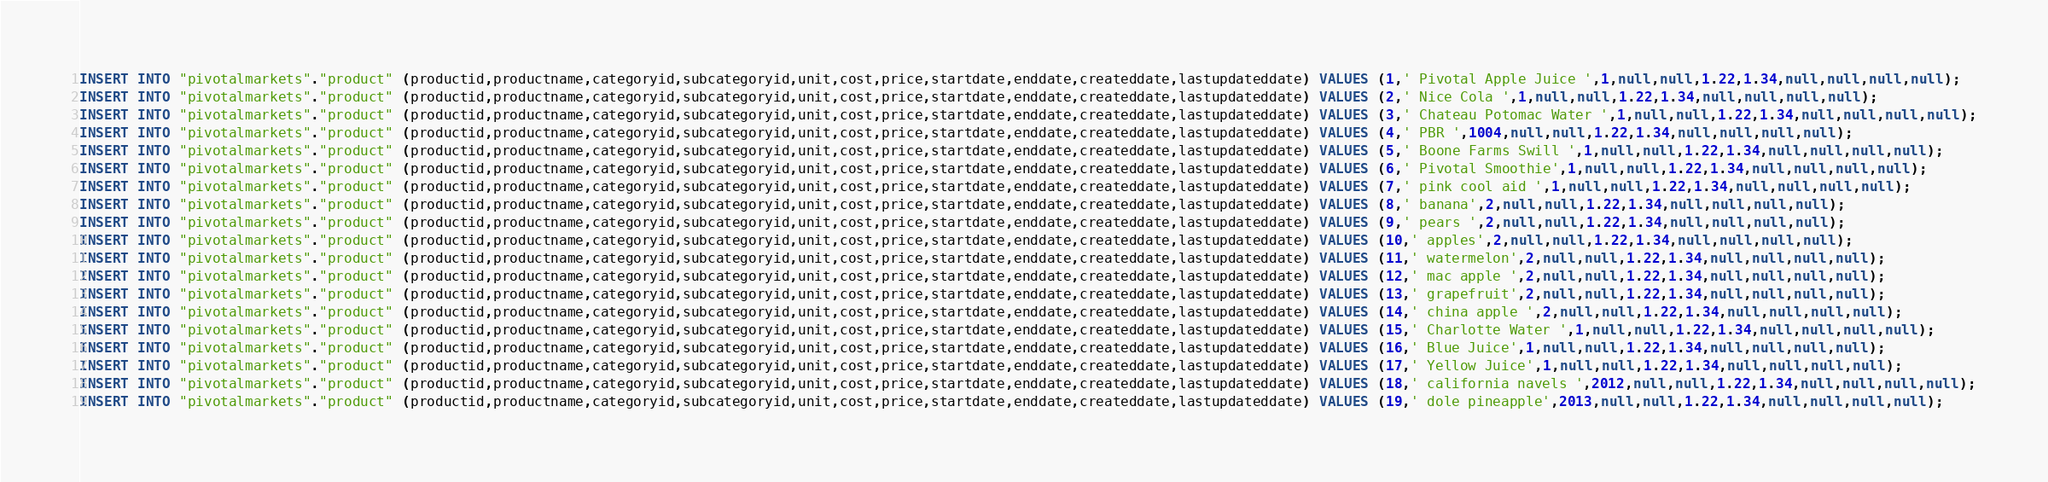<code> <loc_0><loc_0><loc_500><loc_500><_SQL_>

INSERT INTO "pivotalmarkets"."product" (productid,productname,categoryid,subcategoryid,unit,cost,price,startdate,enddate,createddate,lastupdateddate) VALUES (1,' Pivotal Apple Juice ',1,null,null,1.22,1.34,null,null,null,null);
INSERT INTO "pivotalmarkets"."product" (productid,productname,categoryid,subcategoryid,unit,cost,price,startdate,enddate,createddate,lastupdateddate) VALUES (2,' Nice Cola ',1,null,null,1.22,1.34,null,null,null,null);
INSERT INTO "pivotalmarkets"."product" (productid,productname,categoryid,subcategoryid,unit,cost,price,startdate,enddate,createddate,lastupdateddate) VALUES (3,' Chateau Potomac Water ',1,null,null,1.22,1.34,null,null,null,null);
INSERT INTO "pivotalmarkets"."product" (productid,productname,categoryid,subcategoryid,unit,cost,price,startdate,enddate,createddate,lastupdateddate) VALUES (4,' PBR ',1004,null,null,1.22,1.34,null,null,null,null);
INSERT INTO "pivotalmarkets"."product" (productid,productname,categoryid,subcategoryid,unit,cost,price,startdate,enddate,createddate,lastupdateddate) VALUES (5,' Boone Farms Swill ',1,null,null,1.22,1.34,null,null,null,null);
INSERT INTO "pivotalmarkets"."product" (productid,productname,categoryid,subcategoryid,unit,cost,price,startdate,enddate,createddate,lastupdateddate) VALUES (6,' Pivotal Smoothie',1,null,null,1.22,1.34,null,null,null,null);
INSERT INTO "pivotalmarkets"."product" (productid,productname,categoryid,subcategoryid,unit,cost,price,startdate,enddate,createddate,lastupdateddate) VALUES (7,' pink cool aid ',1,null,null,1.22,1.34,null,null,null,null);
INSERT INTO "pivotalmarkets"."product" (productid,productname,categoryid,subcategoryid,unit,cost,price,startdate,enddate,createddate,lastupdateddate) VALUES (8,' banana',2,null,null,1.22,1.34,null,null,null,null);
INSERT INTO "pivotalmarkets"."product" (productid,productname,categoryid,subcategoryid,unit,cost,price,startdate,enddate,createddate,lastupdateddate) VALUES (9,' pears ',2,null,null,1.22,1.34,null,null,null,null);
INSERT INTO "pivotalmarkets"."product" (productid,productname,categoryid,subcategoryid,unit,cost,price,startdate,enddate,createddate,lastupdateddate) VALUES (10,' apples',2,null,null,1.22,1.34,null,null,null,null);
INSERT INTO "pivotalmarkets"."product" (productid,productname,categoryid,subcategoryid,unit,cost,price,startdate,enddate,createddate,lastupdateddate) VALUES (11,' watermelon',2,null,null,1.22,1.34,null,null,null,null);
INSERT INTO "pivotalmarkets"."product" (productid,productname,categoryid,subcategoryid,unit,cost,price,startdate,enddate,createddate,lastupdateddate) VALUES (12,' mac apple ',2,null,null,1.22,1.34,null,null,null,null);
INSERT INTO "pivotalmarkets"."product" (productid,productname,categoryid,subcategoryid,unit,cost,price,startdate,enddate,createddate,lastupdateddate) VALUES (13,' grapefruit',2,null,null,1.22,1.34,null,null,null,null);
INSERT INTO "pivotalmarkets"."product" (productid,productname,categoryid,subcategoryid,unit,cost,price,startdate,enddate,createddate,lastupdateddate) VALUES (14,' china apple ',2,null,null,1.22,1.34,null,null,null,null);
INSERT INTO "pivotalmarkets"."product" (productid,productname,categoryid,subcategoryid,unit,cost,price,startdate,enddate,createddate,lastupdateddate) VALUES (15,' Charlotte Water ',1,null,null,1.22,1.34,null,null,null,null);
INSERT INTO "pivotalmarkets"."product" (productid,productname,categoryid,subcategoryid,unit,cost,price,startdate,enddate,createddate,lastupdateddate) VALUES (16,' Blue Juice',1,null,null,1.22,1.34,null,null,null,null);
INSERT INTO "pivotalmarkets"."product" (productid,productname,categoryid,subcategoryid,unit,cost,price,startdate,enddate,createddate,lastupdateddate) VALUES (17,' Yellow Juice',1,null,null,1.22,1.34,null,null,null,null);
INSERT INTO "pivotalmarkets"."product" (productid,productname,categoryid,subcategoryid,unit,cost,price,startdate,enddate,createddate,lastupdateddate) VALUES (18,' california navels ',2012,null,null,1.22,1.34,null,null,null,null);
INSERT INTO "pivotalmarkets"."product" (productid,productname,categoryid,subcategoryid,unit,cost,price,startdate,enddate,createddate,lastupdateddate) VALUES (19,' dole pineapple',2013,null,null,1.22,1.34,null,null,null,null);</code> 